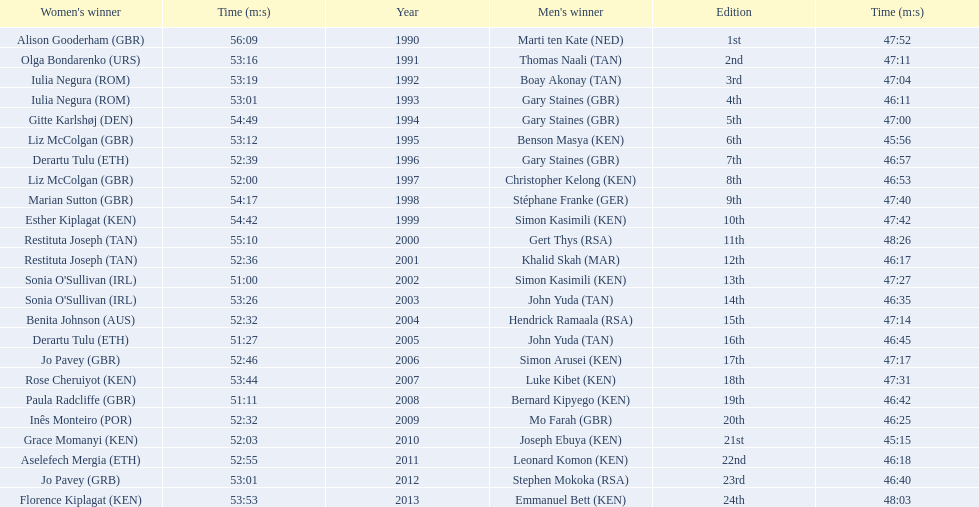What are the names of each male winner? Marti ten Kate (NED), Thomas Naali (TAN), Boay Akonay (TAN), Gary Staines (GBR), Gary Staines (GBR), Benson Masya (KEN), Gary Staines (GBR), Christopher Kelong (KEN), Stéphane Franke (GER), Simon Kasimili (KEN), Gert Thys (RSA), Khalid Skah (MAR), Simon Kasimili (KEN), John Yuda (TAN), Hendrick Ramaala (RSA), John Yuda (TAN), Simon Arusei (KEN), Luke Kibet (KEN), Bernard Kipyego (KEN), Mo Farah (GBR), Joseph Ebuya (KEN), Leonard Komon (KEN), Stephen Mokoka (RSA), Emmanuel Bett (KEN). When did they race? 1990, 1991, 1992, 1993, 1994, 1995, 1996, 1997, 1998, 1999, 2000, 2001, 2002, 2003, 2004, 2005, 2006, 2007, 2008, 2009, 2010, 2011, 2012, 2013. And what were their times? 47:52, 47:11, 47:04, 46:11, 47:00, 45:56, 46:57, 46:53, 47:40, 47:42, 48:26, 46:17, 47:27, 46:35, 47:14, 46:45, 47:17, 47:31, 46:42, 46:25, 45:15, 46:18, 46:40, 48:03. Of those times, which athlete had the fastest time? Joseph Ebuya (KEN). 